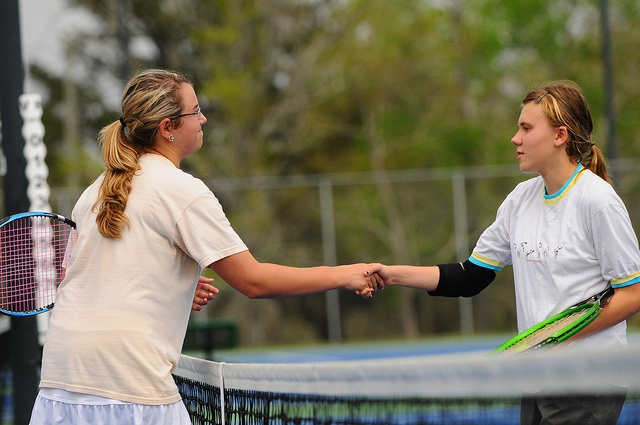Describe the objects in this image and their specific colors. I can see people in black, lightgray, tan, and brown tones, people in black, lightgray, darkgray, and gray tones, tennis racket in black, lightpink, brown, and lightgray tones, and tennis racket in black, darkgray, lime, and tan tones in this image. 